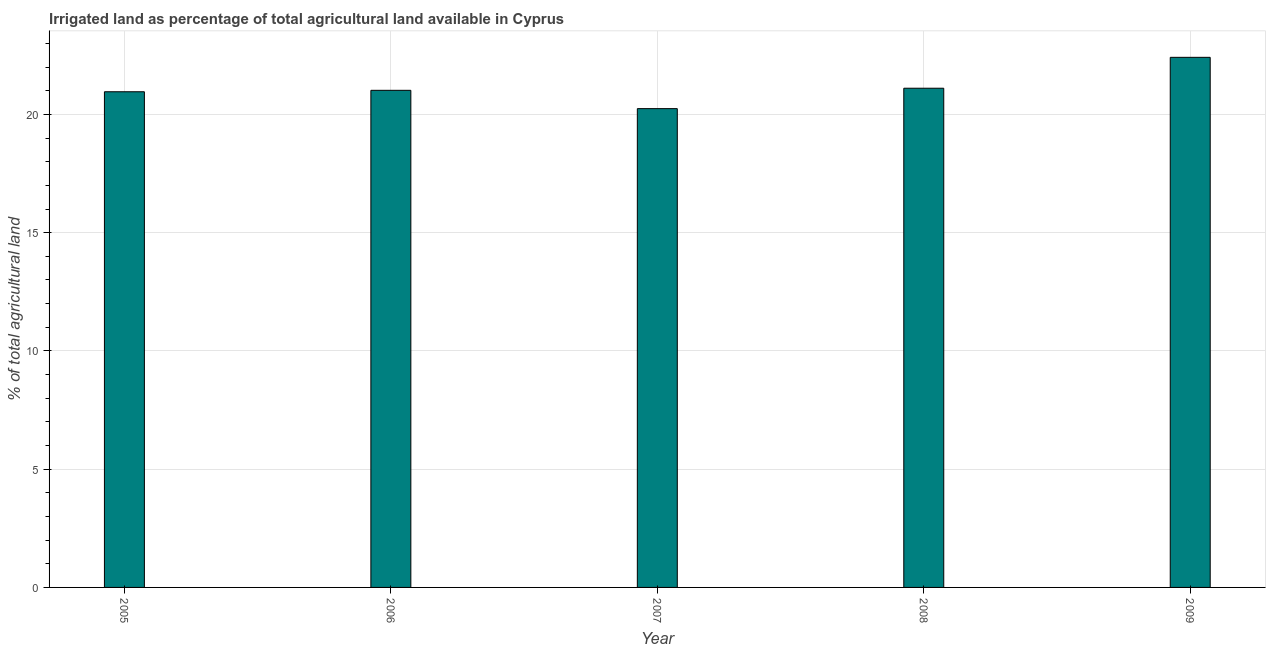Does the graph contain any zero values?
Offer a terse response. No. Does the graph contain grids?
Ensure brevity in your answer.  Yes. What is the title of the graph?
Give a very brief answer. Irrigated land as percentage of total agricultural land available in Cyprus. What is the label or title of the X-axis?
Give a very brief answer. Year. What is the label or title of the Y-axis?
Offer a terse response. % of total agricultural land. What is the percentage of agricultural irrigated land in 2009?
Provide a succinct answer. 22.41. Across all years, what is the maximum percentage of agricultural irrigated land?
Your response must be concise. 22.41. Across all years, what is the minimum percentage of agricultural irrigated land?
Keep it short and to the point. 20.24. In which year was the percentage of agricultural irrigated land maximum?
Provide a succinct answer. 2009. In which year was the percentage of agricultural irrigated land minimum?
Your answer should be very brief. 2007. What is the sum of the percentage of agricultural irrigated land?
Your answer should be very brief. 105.74. What is the difference between the percentage of agricultural irrigated land in 2007 and 2008?
Provide a short and direct response. -0.86. What is the average percentage of agricultural irrigated land per year?
Provide a succinct answer. 21.15. What is the median percentage of agricultural irrigated land?
Make the answer very short. 21.02. In how many years, is the percentage of agricultural irrigated land greater than 6 %?
Offer a very short reply. 5. Do a majority of the years between 2006 and 2005 (inclusive) have percentage of agricultural irrigated land greater than 14 %?
Give a very brief answer. No. Is the percentage of agricultural irrigated land in 2008 less than that in 2009?
Offer a terse response. Yes. Is the difference between the percentage of agricultural irrigated land in 2006 and 2008 greater than the difference between any two years?
Offer a terse response. No. What is the difference between the highest and the second highest percentage of agricultural irrigated land?
Offer a terse response. 1.31. Is the sum of the percentage of agricultural irrigated land in 2006 and 2009 greater than the maximum percentage of agricultural irrigated land across all years?
Make the answer very short. Yes. What is the difference between the highest and the lowest percentage of agricultural irrigated land?
Your answer should be very brief. 2.17. In how many years, is the percentage of agricultural irrigated land greater than the average percentage of agricultural irrigated land taken over all years?
Your response must be concise. 1. How many bars are there?
Provide a short and direct response. 5. Are all the bars in the graph horizontal?
Your answer should be compact. No. What is the % of total agricultural land of 2005?
Provide a succinct answer. 20.96. What is the % of total agricultural land in 2006?
Provide a short and direct response. 21.02. What is the % of total agricultural land of 2007?
Your response must be concise. 20.24. What is the % of total agricultural land in 2008?
Ensure brevity in your answer.  21.11. What is the % of total agricultural land in 2009?
Ensure brevity in your answer.  22.41. What is the difference between the % of total agricultural land in 2005 and 2006?
Your answer should be compact. -0.06. What is the difference between the % of total agricultural land in 2005 and 2007?
Offer a terse response. 0.71. What is the difference between the % of total agricultural land in 2005 and 2008?
Make the answer very short. -0.15. What is the difference between the % of total agricultural land in 2005 and 2009?
Keep it short and to the point. -1.46. What is the difference between the % of total agricultural land in 2006 and 2007?
Ensure brevity in your answer.  0.77. What is the difference between the % of total agricultural land in 2006 and 2008?
Provide a short and direct response. -0.09. What is the difference between the % of total agricultural land in 2006 and 2009?
Your answer should be compact. -1.39. What is the difference between the % of total agricultural land in 2007 and 2008?
Offer a terse response. -0.86. What is the difference between the % of total agricultural land in 2007 and 2009?
Your answer should be very brief. -2.17. What is the difference between the % of total agricultural land in 2008 and 2009?
Give a very brief answer. -1.31. What is the ratio of the % of total agricultural land in 2005 to that in 2007?
Offer a very short reply. 1.03. What is the ratio of the % of total agricultural land in 2005 to that in 2008?
Offer a terse response. 0.99. What is the ratio of the % of total agricultural land in 2005 to that in 2009?
Make the answer very short. 0.94. What is the ratio of the % of total agricultural land in 2006 to that in 2007?
Ensure brevity in your answer.  1.04. What is the ratio of the % of total agricultural land in 2006 to that in 2009?
Provide a short and direct response. 0.94. What is the ratio of the % of total agricultural land in 2007 to that in 2008?
Your answer should be very brief. 0.96. What is the ratio of the % of total agricultural land in 2007 to that in 2009?
Offer a very short reply. 0.9. What is the ratio of the % of total agricultural land in 2008 to that in 2009?
Offer a very short reply. 0.94. 